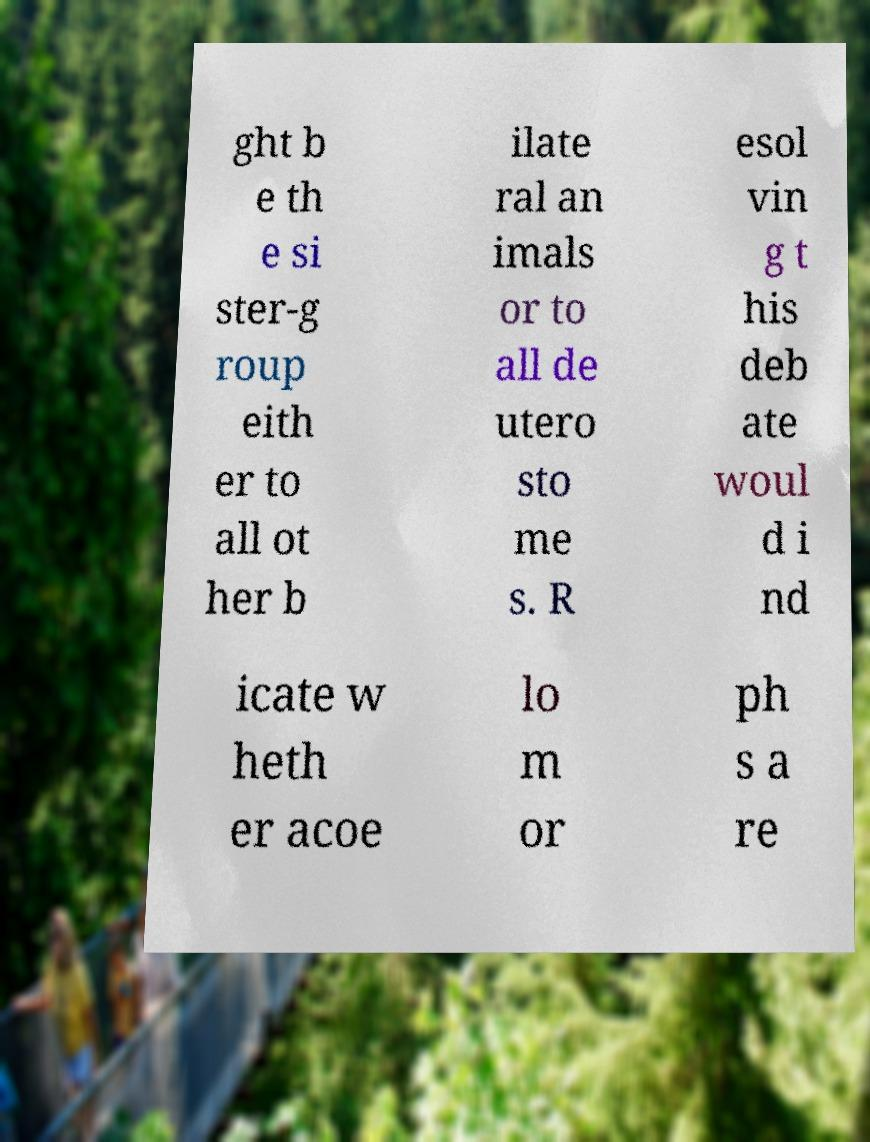Can you read and provide the text displayed in the image?This photo seems to have some interesting text. Can you extract and type it out for me? ght b e th e si ster-g roup eith er to all ot her b ilate ral an imals or to all de utero sto me s. R esol vin g t his deb ate woul d i nd icate w heth er acoe lo m or ph s a re 